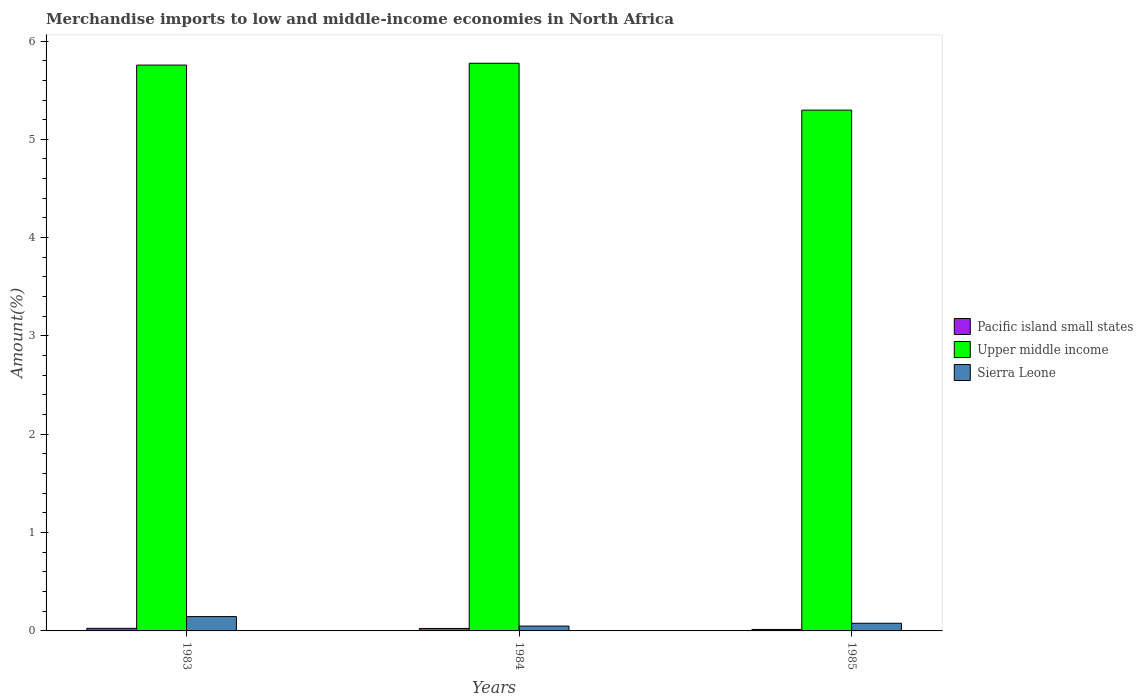Are the number of bars per tick equal to the number of legend labels?
Give a very brief answer. Yes. How many bars are there on the 3rd tick from the left?
Make the answer very short. 3. What is the percentage of amount earned from merchandise imports in Pacific island small states in 1984?
Offer a very short reply. 0.03. Across all years, what is the maximum percentage of amount earned from merchandise imports in Sierra Leone?
Offer a very short reply. 0.15. Across all years, what is the minimum percentage of amount earned from merchandise imports in Upper middle income?
Offer a terse response. 5.3. In which year was the percentage of amount earned from merchandise imports in Pacific island small states maximum?
Make the answer very short. 1983. What is the total percentage of amount earned from merchandise imports in Sierra Leone in the graph?
Provide a short and direct response. 0.27. What is the difference between the percentage of amount earned from merchandise imports in Sierra Leone in 1983 and that in 1984?
Make the answer very short. 0.1. What is the difference between the percentage of amount earned from merchandise imports in Upper middle income in 1985 and the percentage of amount earned from merchandise imports in Pacific island small states in 1984?
Make the answer very short. 5.27. What is the average percentage of amount earned from merchandise imports in Upper middle income per year?
Offer a terse response. 5.61. In the year 1984, what is the difference between the percentage of amount earned from merchandise imports in Sierra Leone and percentage of amount earned from merchandise imports in Pacific island small states?
Keep it short and to the point. 0.02. In how many years, is the percentage of amount earned from merchandise imports in Sierra Leone greater than 2.4 %?
Provide a succinct answer. 0. What is the ratio of the percentage of amount earned from merchandise imports in Pacific island small states in 1983 to that in 1985?
Give a very brief answer. 1.76. What is the difference between the highest and the second highest percentage of amount earned from merchandise imports in Sierra Leone?
Your answer should be very brief. 0.07. What is the difference between the highest and the lowest percentage of amount earned from merchandise imports in Sierra Leone?
Ensure brevity in your answer.  0.1. What does the 1st bar from the left in 1985 represents?
Your answer should be compact. Pacific island small states. What does the 3rd bar from the right in 1984 represents?
Your response must be concise. Pacific island small states. Is it the case that in every year, the sum of the percentage of amount earned from merchandise imports in Sierra Leone and percentage of amount earned from merchandise imports in Pacific island small states is greater than the percentage of amount earned from merchandise imports in Upper middle income?
Give a very brief answer. No. Are all the bars in the graph horizontal?
Offer a terse response. No. What is the difference between two consecutive major ticks on the Y-axis?
Your answer should be compact. 1. Are the values on the major ticks of Y-axis written in scientific E-notation?
Provide a succinct answer. No. Does the graph contain any zero values?
Offer a terse response. No. Does the graph contain grids?
Keep it short and to the point. No. How many legend labels are there?
Provide a short and direct response. 3. How are the legend labels stacked?
Provide a succinct answer. Vertical. What is the title of the graph?
Offer a very short reply. Merchandise imports to low and middle-income economies in North Africa. Does "Barbados" appear as one of the legend labels in the graph?
Ensure brevity in your answer.  No. What is the label or title of the X-axis?
Provide a short and direct response. Years. What is the label or title of the Y-axis?
Provide a succinct answer. Amount(%). What is the Amount(%) of Pacific island small states in 1983?
Provide a succinct answer. 0.03. What is the Amount(%) in Upper middle income in 1983?
Give a very brief answer. 5.76. What is the Amount(%) of Sierra Leone in 1983?
Provide a succinct answer. 0.15. What is the Amount(%) of Pacific island small states in 1984?
Ensure brevity in your answer.  0.03. What is the Amount(%) of Upper middle income in 1984?
Your response must be concise. 5.77. What is the Amount(%) of Sierra Leone in 1984?
Offer a terse response. 0.05. What is the Amount(%) in Pacific island small states in 1985?
Give a very brief answer. 0.01. What is the Amount(%) in Upper middle income in 1985?
Make the answer very short. 5.3. What is the Amount(%) of Sierra Leone in 1985?
Your answer should be compact. 0.08. Across all years, what is the maximum Amount(%) of Pacific island small states?
Your answer should be compact. 0.03. Across all years, what is the maximum Amount(%) in Upper middle income?
Ensure brevity in your answer.  5.77. Across all years, what is the maximum Amount(%) of Sierra Leone?
Offer a very short reply. 0.15. Across all years, what is the minimum Amount(%) of Pacific island small states?
Ensure brevity in your answer.  0.01. Across all years, what is the minimum Amount(%) in Upper middle income?
Make the answer very short. 5.3. Across all years, what is the minimum Amount(%) in Sierra Leone?
Your answer should be compact. 0.05. What is the total Amount(%) of Pacific island small states in the graph?
Your response must be concise. 0.07. What is the total Amount(%) in Upper middle income in the graph?
Keep it short and to the point. 16.83. What is the total Amount(%) of Sierra Leone in the graph?
Make the answer very short. 0.27. What is the difference between the Amount(%) in Pacific island small states in 1983 and that in 1984?
Your answer should be very brief. 0. What is the difference between the Amount(%) of Upper middle income in 1983 and that in 1984?
Your answer should be compact. -0.02. What is the difference between the Amount(%) in Sierra Leone in 1983 and that in 1984?
Ensure brevity in your answer.  0.1. What is the difference between the Amount(%) in Pacific island small states in 1983 and that in 1985?
Your answer should be very brief. 0.01. What is the difference between the Amount(%) of Upper middle income in 1983 and that in 1985?
Give a very brief answer. 0.46. What is the difference between the Amount(%) of Sierra Leone in 1983 and that in 1985?
Make the answer very short. 0.07. What is the difference between the Amount(%) in Pacific island small states in 1984 and that in 1985?
Your answer should be very brief. 0.01. What is the difference between the Amount(%) in Upper middle income in 1984 and that in 1985?
Offer a terse response. 0.48. What is the difference between the Amount(%) of Sierra Leone in 1984 and that in 1985?
Ensure brevity in your answer.  -0.03. What is the difference between the Amount(%) of Pacific island small states in 1983 and the Amount(%) of Upper middle income in 1984?
Your answer should be very brief. -5.75. What is the difference between the Amount(%) of Pacific island small states in 1983 and the Amount(%) of Sierra Leone in 1984?
Give a very brief answer. -0.02. What is the difference between the Amount(%) of Upper middle income in 1983 and the Amount(%) of Sierra Leone in 1984?
Make the answer very short. 5.71. What is the difference between the Amount(%) in Pacific island small states in 1983 and the Amount(%) in Upper middle income in 1985?
Make the answer very short. -5.27. What is the difference between the Amount(%) in Pacific island small states in 1983 and the Amount(%) in Sierra Leone in 1985?
Give a very brief answer. -0.05. What is the difference between the Amount(%) of Upper middle income in 1983 and the Amount(%) of Sierra Leone in 1985?
Give a very brief answer. 5.68. What is the difference between the Amount(%) in Pacific island small states in 1984 and the Amount(%) in Upper middle income in 1985?
Provide a short and direct response. -5.27. What is the difference between the Amount(%) of Pacific island small states in 1984 and the Amount(%) of Sierra Leone in 1985?
Make the answer very short. -0.05. What is the difference between the Amount(%) in Upper middle income in 1984 and the Amount(%) in Sierra Leone in 1985?
Provide a short and direct response. 5.7. What is the average Amount(%) in Pacific island small states per year?
Make the answer very short. 0.02. What is the average Amount(%) of Upper middle income per year?
Ensure brevity in your answer.  5.61. What is the average Amount(%) in Sierra Leone per year?
Provide a short and direct response. 0.09. In the year 1983, what is the difference between the Amount(%) of Pacific island small states and Amount(%) of Upper middle income?
Offer a terse response. -5.73. In the year 1983, what is the difference between the Amount(%) in Pacific island small states and Amount(%) in Sierra Leone?
Keep it short and to the point. -0.12. In the year 1983, what is the difference between the Amount(%) of Upper middle income and Amount(%) of Sierra Leone?
Offer a very short reply. 5.61. In the year 1984, what is the difference between the Amount(%) in Pacific island small states and Amount(%) in Upper middle income?
Offer a very short reply. -5.75. In the year 1984, what is the difference between the Amount(%) in Pacific island small states and Amount(%) in Sierra Leone?
Your answer should be compact. -0.02. In the year 1984, what is the difference between the Amount(%) of Upper middle income and Amount(%) of Sierra Leone?
Offer a terse response. 5.72. In the year 1985, what is the difference between the Amount(%) of Pacific island small states and Amount(%) of Upper middle income?
Ensure brevity in your answer.  -5.28. In the year 1985, what is the difference between the Amount(%) in Pacific island small states and Amount(%) in Sierra Leone?
Offer a terse response. -0.06. In the year 1985, what is the difference between the Amount(%) in Upper middle income and Amount(%) in Sierra Leone?
Ensure brevity in your answer.  5.22. What is the ratio of the Amount(%) of Pacific island small states in 1983 to that in 1984?
Offer a very short reply. 1.04. What is the ratio of the Amount(%) in Upper middle income in 1983 to that in 1984?
Provide a succinct answer. 1. What is the ratio of the Amount(%) in Sierra Leone in 1983 to that in 1984?
Keep it short and to the point. 2.96. What is the ratio of the Amount(%) of Pacific island small states in 1983 to that in 1985?
Your answer should be very brief. 1.76. What is the ratio of the Amount(%) of Upper middle income in 1983 to that in 1985?
Provide a succinct answer. 1.09. What is the ratio of the Amount(%) of Sierra Leone in 1983 to that in 1985?
Your response must be concise. 1.88. What is the ratio of the Amount(%) of Pacific island small states in 1984 to that in 1985?
Offer a terse response. 1.69. What is the ratio of the Amount(%) in Upper middle income in 1984 to that in 1985?
Provide a succinct answer. 1.09. What is the ratio of the Amount(%) of Sierra Leone in 1984 to that in 1985?
Provide a short and direct response. 0.63. What is the difference between the highest and the second highest Amount(%) of Upper middle income?
Your response must be concise. 0.02. What is the difference between the highest and the second highest Amount(%) in Sierra Leone?
Your answer should be very brief. 0.07. What is the difference between the highest and the lowest Amount(%) in Pacific island small states?
Give a very brief answer. 0.01. What is the difference between the highest and the lowest Amount(%) in Upper middle income?
Provide a succinct answer. 0.48. What is the difference between the highest and the lowest Amount(%) of Sierra Leone?
Make the answer very short. 0.1. 